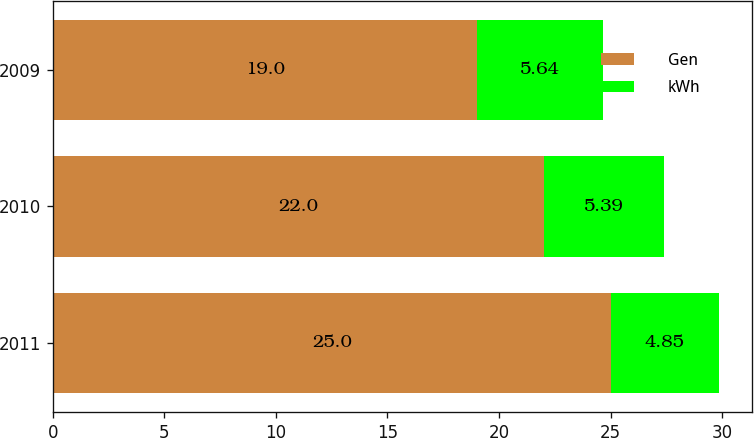<chart> <loc_0><loc_0><loc_500><loc_500><stacked_bar_chart><ecel><fcel>2011<fcel>2010<fcel>2009<nl><fcel>Gen<fcel>25<fcel>22<fcel>19<nl><fcel>kWh<fcel>4.85<fcel>5.39<fcel>5.64<nl></chart> 